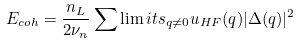<formula> <loc_0><loc_0><loc_500><loc_500>E _ { c o h } = \frac { n _ { L } } { 2 \nu _ { n } } \sum \lim i t s _ { { q } \not { = } 0 } u _ { H F } ( q ) | \Delta ( { q } ) | ^ { 2 }</formula> 